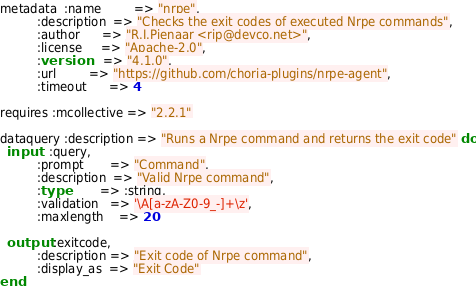<code> <loc_0><loc_0><loc_500><loc_500><_SQL_>metadata  :name         => "nrpe",
          :description  => "Checks the exit codes of executed Nrpe commands",
          :author      => "R.I.Pienaar <rip@devco.net>",
          :license     => "Apache-2.0",
          :version     => "4.1.0",
          :url         => "https://github.com/choria-plugins/nrpe-agent",
          :timeout      => 4

requires :mcollective => "2.2.1"

dataquery :description => "Runs a Nrpe command and returns the exit code" do
  input   :query,
          :prompt       => "Command",
          :description  => "Valid Nrpe command",
          :type         => :string,
          :validation   => '\A[a-zA-Z0-9_-]+\z',
          :maxlength    => 20

  output  :exitcode,
          :description => "Exit code of Nrpe command",
          :display_as  => "Exit Code"
end
</code> 